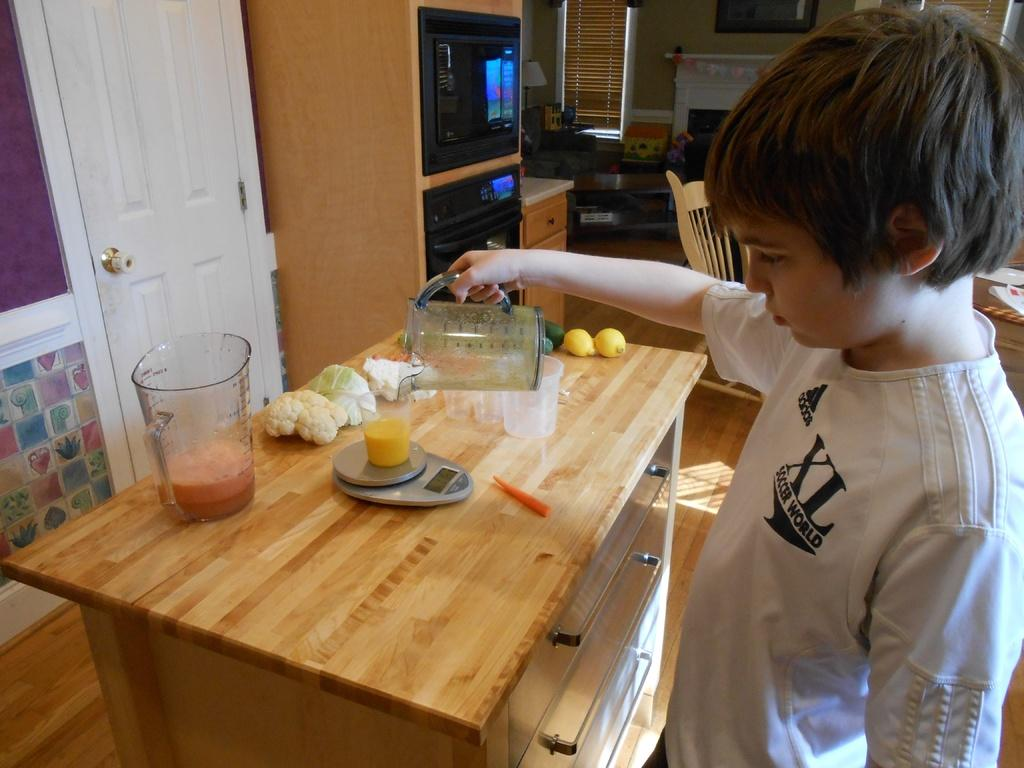Provide a one-sentence caption for the provided image. A boy wearing an XL Soccer World shirt pours a glass of orange juice. 